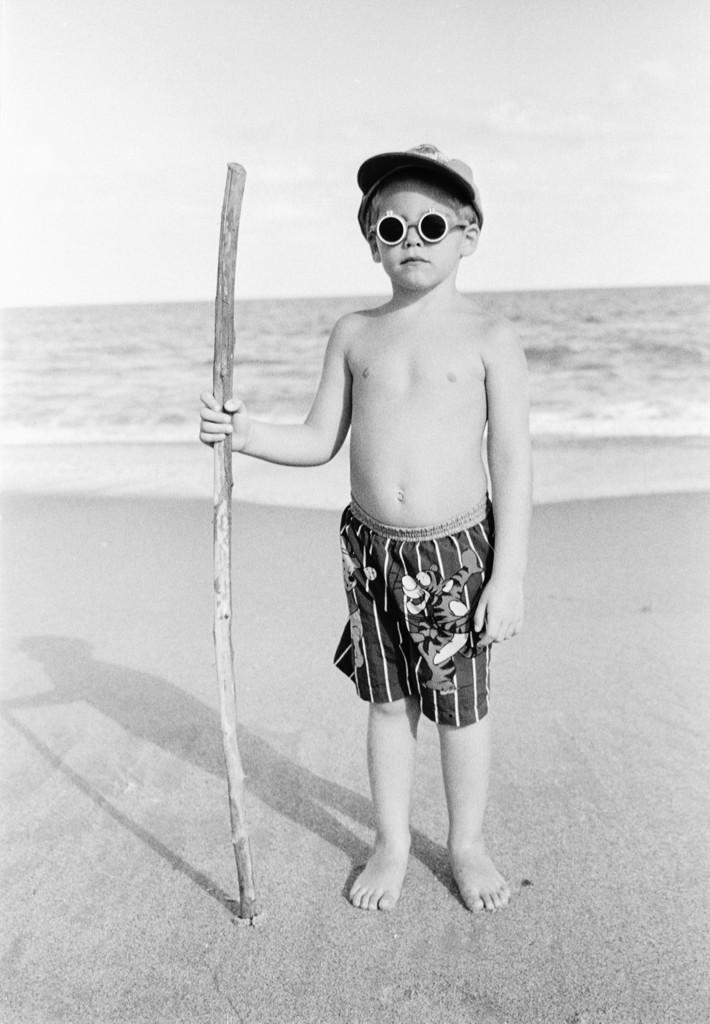What is the color scheme of the image? The image is black and white. What can be seen in the image? There is a kid in the image. What accessories is the kid wearing? The kid is wearing glasses and a cap. What is the kid holding in the image? The kid is holding a stick. What is visible in the background of the image? There is water in the background of the image. What is present at the bottom of the image? There is sand at the bottom of the image. How many plates can be seen on the kid's toes in the image? There are no plates visible on the kid's toes in the image. What type of goose is present in the image? There is no goose present in the image. 